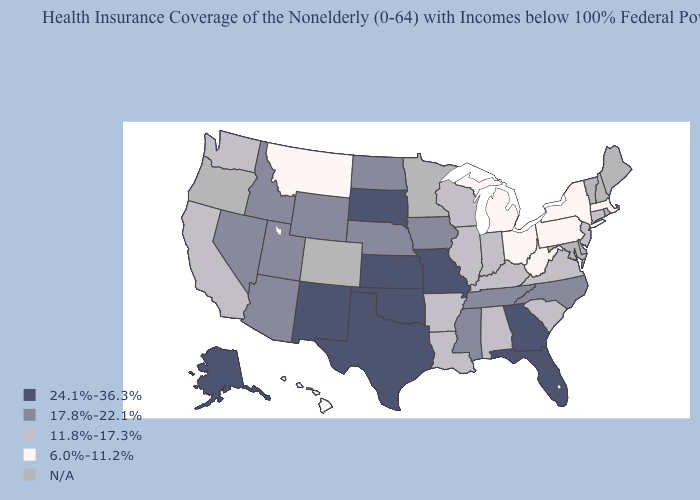What is the highest value in the South ?
Short answer required. 24.1%-36.3%. Among the states that border Delaware , which have the highest value?
Quick response, please. New Jersey. What is the lowest value in the USA?
Give a very brief answer. 6.0%-11.2%. Which states have the highest value in the USA?
Answer briefly. Alaska, Florida, Georgia, Kansas, Missouri, New Mexico, Oklahoma, South Dakota, Texas. Does the first symbol in the legend represent the smallest category?
Concise answer only. No. Which states hav the highest value in the Northeast?
Quick response, please. Connecticut, New Jersey. What is the value of Oregon?
Short answer required. N/A. Which states have the highest value in the USA?
Keep it brief. Alaska, Florida, Georgia, Kansas, Missouri, New Mexico, Oklahoma, South Dakota, Texas. Among the states that border Minnesota , does Iowa have the lowest value?
Write a very short answer. No. Name the states that have a value in the range 24.1%-36.3%?
Concise answer only. Alaska, Florida, Georgia, Kansas, Missouri, New Mexico, Oklahoma, South Dakota, Texas. Name the states that have a value in the range 17.8%-22.1%?
Answer briefly. Arizona, Idaho, Iowa, Mississippi, Nebraska, Nevada, North Carolina, North Dakota, Tennessee, Utah, Wyoming. What is the value of Florida?
Be succinct. 24.1%-36.3%. What is the lowest value in the USA?
Short answer required. 6.0%-11.2%. Among the states that border Florida , which have the lowest value?
Give a very brief answer. Alabama. 